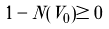<formula> <loc_0><loc_0><loc_500><loc_500>1 - N ( V _ { 0 } ) \geq 0</formula> 